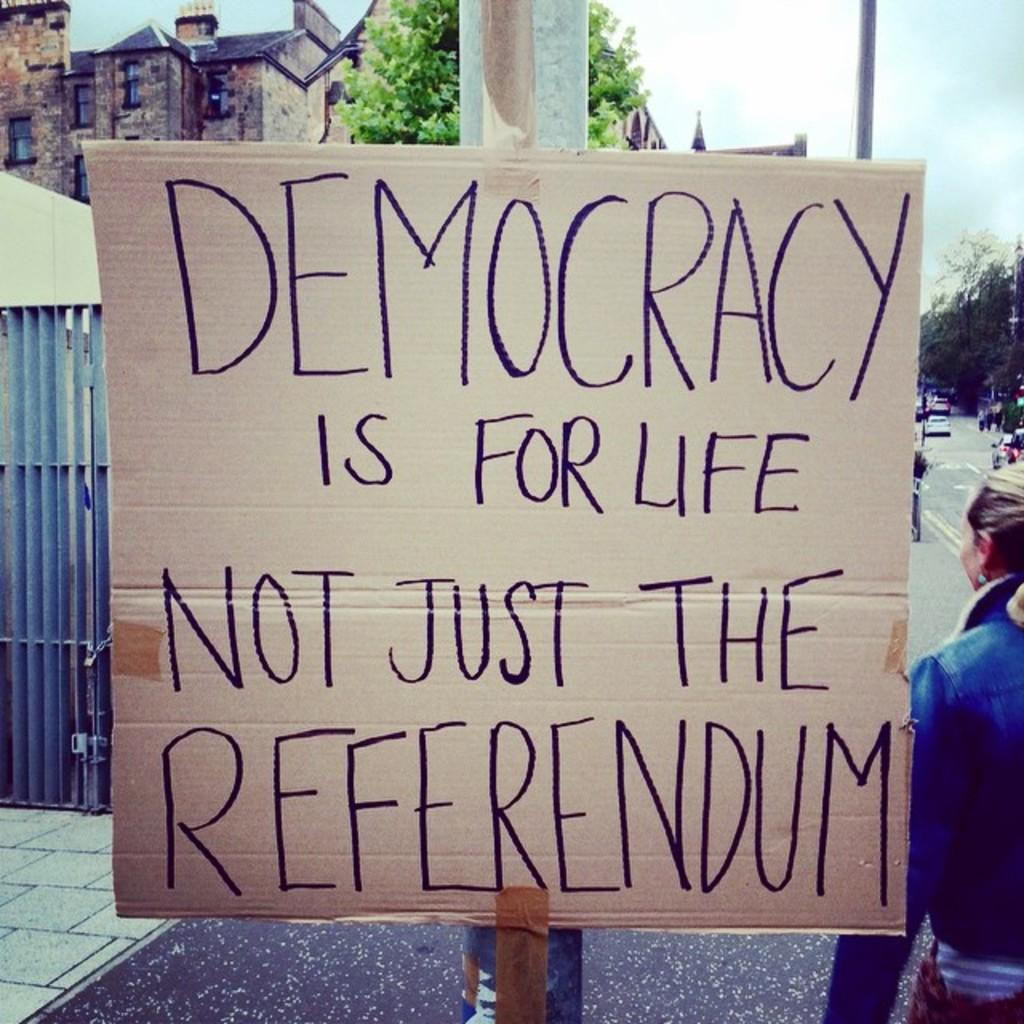What is the main object in the image? There is a board in the image. What is written or displayed on the board? There is text on the board. What type of structures can be seen in the image? There are buildings in the image. What type of vegetation is present in the image? There are trees in the image. What type of transportation can be seen in the image? There are vehicles in the image. What type of vertical structures are present in the image? There are poles in the image. Are there any living beings in the image? Yes, there are people in the image. What is visible in the background of the image? The sky is visible in the background of the image. What can be observed in the sky? There are clouds in the sky. How many cacti are present in the image? There are no cacti present in the image. What year does the image depict? The image does not depict a specific year; it is a snapshot of a scene. What historical event is taking place in the image? There is no historical event taking place in the image; it is a scene of everyday life. 